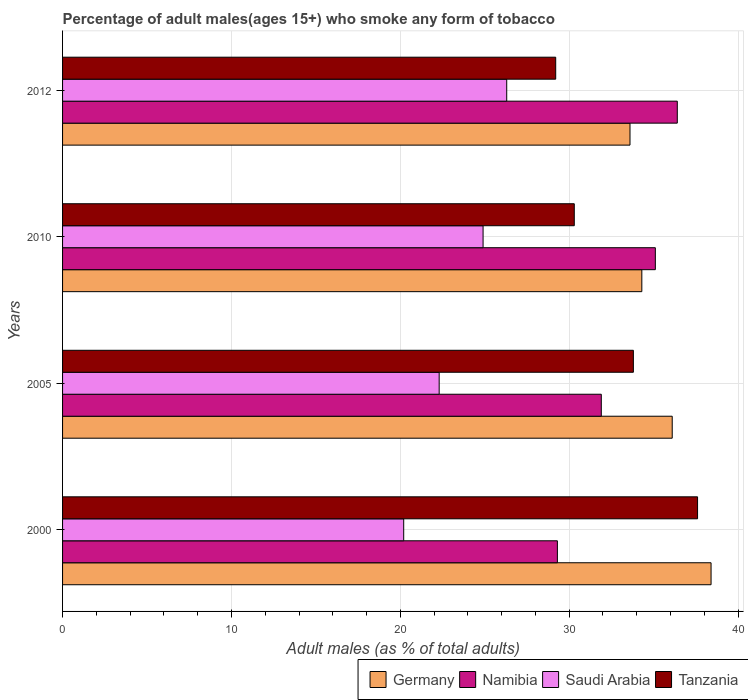How many different coloured bars are there?
Your answer should be very brief. 4. How many groups of bars are there?
Offer a terse response. 4. Are the number of bars per tick equal to the number of legend labels?
Offer a terse response. Yes. In how many cases, is the number of bars for a given year not equal to the number of legend labels?
Keep it short and to the point. 0. What is the percentage of adult males who smoke in Germany in 2000?
Make the answer very short. 38.4. Across all years, what is the maximum percentage of adult males who smoke in Tanzania?
Make the answer very short. 37.6. Across all years, what is the minimum percentage of adult males who smoke in Germany?
Make the answer very short. 33.6. In which year was the percentage of adult males who smoke in Germany maximum?
Make the answer very short. 2000. In which year was the percentage of adult males who smoke in Namibia minimum?
Offer a very short reply. 2000. What is the total percentage of adult males who smoke in Saudi Arabia in the graph?
Keep it short and to the point. 93.7. What is the difference between the percentage of adult males who smoke in Saudi Arabia in 2005 and that in 2010?
Give a very brief answer. -2.6. What is the difference between the percentage of adult males who smoke in Tanzania in 2005 and the percentage of adult males who smoke in Germany in 2000?
Keep it short and to the point. -4.6. What is the average percentage of adult males who smoke in Tanzania per year?
Offer a very short reply. 32.73. In the year 2012, what is the difference between the percentage of adult males who smoke in Germany and percentage of adult males who smoke in Tanzania?
Give a very brief answer. 4.4. What is the ratio of the percentage of adult males who smoke in Tanzania in 2000 to that in 2010?
Make the answer very short. 1.24. Is the percentage of adult males who smoke in Saudi Arabia in 2005 less than that in 2012?
Give a very brief answer. Yes. What is the difference between the highest and the second highest percentage of adult males who smoke in Saudi Arabia?
Provide a short and direct response. 1.4. What is the difference between the highest and the lowest percentage of adult males who smoke in Germany?
Your answer should be compact. 4.8. What does the 1st bar from the top in 2012 represents?
Give a very brief answer. Tanzania. What does the 2nd bar from the bottom in 2010 represents?
Keep it short and to the point. Namibia. How many bars are there?
Make the answer very short. 16. What is the difference between two consecutive major ticks on the X-axis?
Offer a very short reply. 10. Does the graph contain any zero values?
Your answer should be very brief. No. Does the graph contain grids?
Offer a very short reply. Yes. Where does the legend appear in the graph?
Provide a short and direct response. Bottom right. How many legend labels are there?
Provide a short and direct response. 4. What is the title of the graph?
Your answer should be compact. Percentage of adult males(ages 15+) who smoke any form of tobacco. Does "Croatia" appear as one of the legend labels in the graph?
Your response must be concise. No. What is the label or title of the X-axis?
Provide a short and direct response. Adult males (as % of total adults). What is the label or title of the Y-axis?
Your answer should be compact. Years. What is the Adult males (as % of total adults) in Germany in 2000?
Ensure brevity in your answer.  38.4. What is the Adult males (as % of total adults) of Namibia in 2000?
Your response must be concise. 29.3. What is the Adult males (as % of total adults) in Saudi Arabia in 2000?
Your answer should be very brief. 20.2. What is the Adult males (as % of total adults) in Tanzania in 2000?
Make the answer very short. 37.6. What is the Adult males (as % of total adults) of Germany in 2005?
Give a very brief answer. 36.1. What is the Adult males (as % of total adults) in Namibia in 2005?
Your response must be concise. 31.9. What is the Adult males (as % of total adults) of Saudi Arabia in 2005?
Your answer should be compact. 22.3. What is the Adult males (as % of total adults) in Tanzania in 2005?
Your answer should be compact. 33.8. What is the Adult males (as % of total adults) in Germany in 2010?
Ensure brevity in your answer.  34.3. What is the Adult males (as % of total adults) of Namibia in 2010?
Your answer should be very brief. 35.1. What is the Adult males (as % of total adults) in Saudi Arabia in 2010?
Give a very brief answer. 24.9. What is the Adult males (as % of total adults) of Tanzania in 2010?
Provide a succinct answer. 30.3. What is the Adult males (as % of total adults) in Germany in 2012?
Your answer should be very brief. 33.6. What is the Adult males (as % of total adults) in Namibia in 2012?
Ensure brevity in your answer.  36.4. What is the Adult males (as % of total adults) in Saudi Arabia in 2012?
Offer a terse response. 26.3. What is the Adult males (as % of total adults) in Tanzania in 2012?
Offer a very short reply. 29.2. Across all years, what is the maximum Adult males (as % of total adults) of Germany?
Provide a succinct answer. 38.4. Across all years, what is the maximum Adult males (as % of total adults) of Namibia?
Give a very brief answer. 36.4. Across all years, what is the maximum Adult males (as % of total adults) of Saudi Arabia?
Provide a short and direct response. 26.3. Across all years, what is the maximum Adult males (as % of total adults) of Tanzania?
Provide a short and direct response. 37.6. Across all years, what is the minimum Adult males (as % of total adults) in Germany?
Your answer should be very brief. 33.6. Across all years, what is the minimum Adult males (as % of total adults) of Namibia?
Provide a succinct answer. 29.3. Across all years, what is the minimum Adult males (as % of total adults) in Saudi Arabia?
Offer a very short reply. 20.2. Across all years, what is the minimum Adult males (as % of total adults) of Tanzania?
Your answer should be compact. 29.2. What is the total Adult males (as % of total adults) in Germany in the graph?
Offer a terse response. 142.4. What is the total Adult males (as % of total adults) of Namibia in the graph?
Your answer should be compact. 132.7. What is the total Adult males (as % of total adults) of Saudi Arabia in the graph?
Your answer should be compact. 93.7. What is the total Adult males (as % of total adults) of Tanzania in the graph?
Make the answer very short. 130.9. What is the difference between the Adult males (as % of total adults) in Namibia in 2000 and that in 2005?
Ensure brevity in your answer.  -2.6. What is the difference between the Adult males (as % of total adults) in Saudi Arabia in 2000 and that in 2005?
Keep it short and to the point. -2.1. What is the difference between the Adult males (as % of total adults) in Tanzania in 2000 and that in 2005?
Your answer should be compact. 3.8. What is the difference between the Adult males (as % of total adults) of Germany in 2000 and that in 2010?
Ensure brevity in your answer.  4.1. What is the difference between the Adult males (as % of total adults) in Saudi Arabia in 2000 and that in 2010?
Your response must be concise. -4.7. What is the difference between the Adult males (as % of total adults) of Namibia in 2005 and that in 2010?
Your answer should be compact. -3.2. What is the difference between the Adult males (as % of total adults) of Saudi Arabia in 2005 and that in 2010?
Your response must be concise. -2.6. What is the difference between the Adult males (as % of total adults) in Tanzania in 2005 and that in 2010?
Ensure brevity in your answer.  3.5. What is the difference between the Adult males (as % of total adults) of Germany in 2005 and that in 2012?
Provide a short and direct response. 2.5. What is the difference between the Adult males (as % of total adults) in Namibia in 2005 and that in 2012?
Give a very brief answer. -4.5. What is the difference between the Adult males (as % of total adults) in Saudi Arabia in 2005 and that in 2012?
Keep it short and to the point. -4. What is the difference between the Adult males (as % of total adults) in Saudi Arabia in 2010 and that in 2012?
Your answer should be very brief. -1.4. What is the difference between the Adult males (as % of total adults) in Germany in 2000 and the Adult males (as % of total adults) in Saudi Arabia in 2005?
Ensure brevity in your answer.  16.1. What is the difference between the Adult males (as % of total adults) of Saudi Arabia in 2000 and the Adult males (as % of total adults) of Tanzania in 2005?
Offer a terse response. -13.6. What is the difference between the Adult males (as % of total adults) of Germany in 2000 and the Adult males (as % of total adults) of Namibia in 2010?
Your answer should be compact. 3.3. What is the difference between the Adult males (as % of total adults) in Germany in 2000 and the Adult males (as % of total adults) in Saudi Arabia in 2010?
Your response must be concise. 13.5. What is the difference between the Adult males (as % of total adults) of Namibia in 2000 and the Adult males (as % of total adults) of Tanzania in 2010?
Give a very brief answer. -1. What is the difference between the Adult males (as % of total adults) of Germany in 2000 and the Adult males (as % of total adults) of Saudi Arabia in 2012?
Ensure brevity in your answer.  12.1. What is the difference between the Adult males (as % of total adults) in Namibia in 2000 and the Adult males (as % of total adults) in Saudi Arabia in 2012?
Offer a terse response. 3. What is the difference between the Adult males (as % of total adults) in Saudi Arabia in 2000 and the Adult males (as % of total adults) in Tanzania in 2012?
Offer a very short reply. -9. What is the difference between the Adult males (as % of total adults) in Germany in 2005 and the Adult males (as % of total adults) in Saudi Arabia in 2010?
Keep it short and to the point. 11.2. What is the difference between the Adult males (as % of total adults) of Namibia in 2005 and the Adult males (as % of total adults) of Saudi Arabia in 2010?
Provide a succinct answer. 7. What is the difference between the Adult males (as % of total adults) of Namibia in 2005 and the Adult males (as % of total adults) of Tanzania in 2010?
Ensure brevity in your answer.  1.6. What is the difference between the Adult males (as % of total adults) in Saudi Arabia in 2005 and the Adult males (as % of total adults) in Tanzania in 2010?
Provide a succinct answer. -8. What is the difference between the Adult males (as % of total adults) of Germany in 2005 and the Adult males (as % of total adults) of Namibia in 2012?
Your response must be concise. -0.3. What is the difference between the Adult males (as % of total adults) of Namibia in 2005 and the Adult males (as % of total adults) of Saudi Arabia in 2012?
Give a very brief answer. 5.6. What is the difference between the Adult males (as % of total adults) in Namibia in 2010 and the Adult males (as % of total adults) in Saudi Arabia in 2012?
Ensure brevity in your answer.  8.8. What is the difference between the Adult males (as % of total adults) in Namibia in 2010 and the Adult males (as % of total adults) in Tanzania in 2012?
Offer a very short reply. 5.9. What is the average Adult males (as % of total adults) in Germany per year?
Keep it short and to the point. 35.6. What is the average Adult males (as % of total adults) in Namibia per year?
Offer a very short reply. 33.17. What is the average Adult males (as % of total adults) in Saudi Arabia per year?
Offer a very short reply. 23.43. What is the average Adult males (as % of total adults) in Tanzania per year?
Give a very brief answer. 32.73. In the year 2000, what is the difference between the Adult males (as % of total adults) of Germany and Adult males (as % of total adults) of Namibia?
Your answer should be very brief. 9.1. In the year 2000, what is the difference between the Adult males (as % of total adults) of Namibia and Adult males (as % of total adults) of Tanzania?
Your response must be concise. -8.3. In the year 2000, what is the difference between the Adult males (as % of total adults) of Saudi Arabia and Adult males (as % of total adults) of Tanzania?
Give a very brief answer. -17.4. In the year 2005, what is the difference between the Adult males (as % of total adults) in Germany and Adult males (as % of total adults) in Namibia?
Offer a very short reply. 4.2. In the year 2005, what is the difference between the Adult males (as % of total adults) in Germany and Adult males (as % of total adults) in Saudi Arabia?
Provide a succinct answer. 13.8. In the year 2005, what is the difference between the Adult males (as % of total adults) of Germany and Adult males (as % of total adults) of Tanzania?
Your answer should be very brief. 2.3. In the year 2005, what is the difference between the Adult males (as % of total adults) in Namibia and Adult males (as % of total adults) in Saudi Arabia?
Keep it short and to the point. 9.6. In the year 2005, what is the difference between the Adult males (as % of total adults) in Namibia and Adult males (as % of total adults) in Tanzania?
Keep it short and to the point. -1.9. In the year 2005, what is the difference between the Adult males (as % of total adults) of Saudi Arabia and Adult males (as % of total adults) of Tanzania?
Your response must be concise. -11.5. In the year 2010, what is the difference between the Adult males (as % of total adults) in Germany and Adult males (as % of total adults) in Tanzania?
Provide a succinct answer. 4. In the year 2010, what is the difference between the Adult males (as % of total adults) in Namibia and Adult males (as % of total adults) in Saudi Arabia?
Your answer should be very brief. 10.2. In the year 2010, what is the difference between the Adult males (as % of total adults) in Namibia and Adult males (as % of total adults) in Tanzania?
Make the answer very short. 4.8. In the year 2010, what is the difference between the Adult males (as % of total adults) in Saudi Arabia and Adult males (as % of total adults) in Tanzania?
Your response must be concise. -5.4. In the year 2012, what is the difference between the Adult males (as % of total adults) of Germany and Adult males (as % of total adults) of Saudi Arabia?
Give a very brief answer. 7.3. In the year 2012, what is the difference between the Adult males (as % of total adults) of Germany and Adult males (as % of total adults) of Tanzania?
Your answer should be compact. 4.4. In the year 2012, what is the difference between the Adult males (as % of total adults) in Namibia and Adult males (as % of total adults) in Saudi Arabia?
Keep it short and to the point. 10.1. In the year 2012, what is the difference between the Adult males (as % of total adults) in Namibia and Adult males (as % of total adults) in Tanzania?
Provide a short and direct response. 7.2. What is the ratio of the Adult males (as % of total adults) of Germany in 2000 to that in 2005?
Your answer should be compact. 1.06. What is the ratio of the Adult males (as % of total adults) of Namibia in 2000 to that in 2005?
Give a very brief answer. 0.92. What is the ratio of the Adult males (as % of total adults) of Saudi Arabia in 2000 to that in 2005?
Give a very brief answer. 0.91. What is the ratio of the Adult males (as % of total adults) of Tanzania in 2000 to that in 2005?
Offer a very short reply. 1.11. What is the ratio of the Adult males (as % of total adults) in Germany in 2000 to that in 2010?
Give a very brief answer. 1.12. What is the ratio of the Adult males (as % of total adults) in Namibia in 2000 to that in 2010?
Provide a short and direct response. 0.83. What is the ratio of the Adult males (as % of total adults) of Saudi Arabia in 2000 to that in 2010?
Your answer should be very brief. 0.81. What is the ratio of the Adult males (as % of total adults) in Tanzania in 2000 to that in 2010?
Your answer should be very brief. 1.24. What is the ratio of the Adult males (as % of total adults) in Germany in 2000 to that in 2012?
Make the answer very short. 1.14. What is the ratio of the Adult males (as % of total adults) in Namibia in 2000 to that in 2012?
Offer a very short reply. 0.8. What is the ratio of the Adult males (as % of total adults) in Saudi Arabia in 2000 to that in 2012?
Keep it short and to the point. 0.77. What is the ratio of the Adult males (as % of total adults) of Tanzania in 2000 to that in 2012?
Give a very brief answer. 1.29. What is the ratio of the Adult males (as % of total adults) in Germany in 2005 to that in 2010?
Offer a very short reply. 1.05. What is the ratio of the Adult males (as % of total adults) of Namibia in 2005 to that in 2010?
Your response must be concise. 0.91. What is the ratio of the Adult males (as % of total adults) of Saudi Arabia in 2005 to that in 2010?
Ensure brevity in your answer.  0.9. What is the ratio of the Adult males (as % of total adults) in Tanzania in 2005 to that in 2010?
Offer a terse response. 1.12. What is the ratio of the Adult males (as % of total adults) of Germany in 2005 to that in 2012?
Provide a succinct answer. 1.07. What is the ratio of the Adult males (as % of total adults) in Namibia in 2005 to that in 2012?
Offer a terse response. 0.88. What is the ratio of the Adult males (as % of total adults) of Saudi Arabia in 2005 to that in 2012?
Give a very brief answer. 0.85. What is the ratio of the Adult males (as % of total adults) of Tanzania in 2005 to that in 2012?
Offer a very short reply. 1.16. What is the ratio of the Adult males (as % of total adults) of Germany in 2010 to that in 2012?
Make the answer very short. 1.02. What is the ratio of the Adult males (as % of total adults) of Namibia in 2010 to that in 2012?
Your answer should be very brief. 0.96. What is the ratio of the Adult males (as % of total adults) of Saudi Arabia in 2010 to that in 2012?
Your answer should be very brief. 0.95. What is the ratio of the Adult males (as % of total adults) in Tanzania in 2010 to that in 2012?
Ensure brevity in your answer.  1.04. What is the difference between the highest and the second highest Adult males (as % of total adults) of Germany?
Your response must be concise. 2.3. What is the difference between the highest and the second highest Adult males (as % of total adults) of Tanzania?
Your response must be concise. 3.8. What is the difference between the highest and the lowest Adult males (as % of total adults) of Germany?
Your answer should be very brief. 4.8. What is the difference between the highest and the lowest Adult males (as % of total adults) of Saudi Arabia?
Give a very brief answer. 6.1. What is the difference between the highest and the lowest Adult males (as % of total adults) in Tanzania?
Provide a succinct answer. 8.4. 